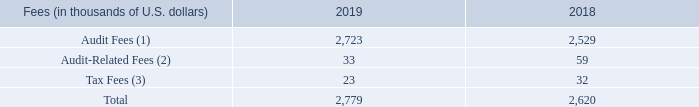Item 16C. Principal Accountant Fees and Services
Our principal accountant for 2019 and 2018 was KPMG LLP, Chartered Professional Accountants. The following table shows the fees Teekay and our subsidiaries paid or accrued for audit and other services provided by KPMG LLP for 2019 and 2018.
(1) Audit fees represent fees for professional services provided in connection with the audits of our consolidated financial statements and effectiveness of internal control over financial reporting, reviews of our quarterly consolidated financial statements and audit services provided in connection with other statutory or regulatory filings for Teekay or our subsidiaries including professional services in connection with the review of our regulatory filings for public offerings of our subsidiaries.
Audit fees for 2019 and 2018 include approximately $928,300 and $859,000, respectively, of fees paid to KPMG LLP by Teekay LNG that were approved by the Audit Committee of the Board of Directors of the general partner of Teekay LNG. Audit fees for 2019 and 2018 include approximately $588,200 and $517,000, respectively, of fees paid to KPMG LLP by our subsidiary Teekay Tankers that were approved by the Audit Committee of the Board of Directors of Teekay Tankers.
(2) Audit-related fees consisted primarily of accounting consultations, employee benefit plan audits, services related to business acquisitions, divestitures and other attestation services. (3) For 2019 and 2018, tax fees principally included corporate tax compliance fees.
The Audit Committee has the authority to pre-approve audit-related and non-audit services not prohibited by law to be performed by our independent auditors and associated fees. Engagements for proposed services either may be separately pre-approved by the Audit Committee or entered into pursuant to detailed pre-approval policies and procedures established by the Audit Committee, as long as the Audit Committee is informed on a timely basis of any engagement entered into on that basis.
The Audit Committee separately pre-approved all engagements and fees paid to our principal accountants in 2019 and 2018.
Who was the principal accountant for 2019 and 2018? Our principal accountant for 2019 and 2018 was kpmg llp, chartered professional accountants. What fees was paid to KPMG LLP by Teekay Tankers during 2019 and 2018? Audit fees for 2019 and 2018 include approximately $588,200 and $517,000, respectively, of fees paid to kpmg llp by our subsidiary teekay tankers that were approved by the audit committee of the board of directors of teekay tankers. What fees was paid to KPMG LLP by Teekay LNG during 2019 and 2018? Audit fees for 2019 and 2018 include approximately $928,300 and $859,000, respectively, of fees paid to kpmg llp by teekay lng that were approved by the audit committee of the board of directors of the general partner of teekay lng. What is the increase/ (decrease) in Audit Fees from 2019 to 2018?
Answer scale should be: thousand. 2,723-2,529
Answer: 194. What is the increase/ (decrease) in Audit-Related Fees from 2019 to 2018?
Answer scale should be: thousand. 33-59
Answer: -26. What is the increase/ (decrease) in Tax Fees from 2019 to 2018?
Answer scale should be: thousand. 23-32
Answer: -9. 